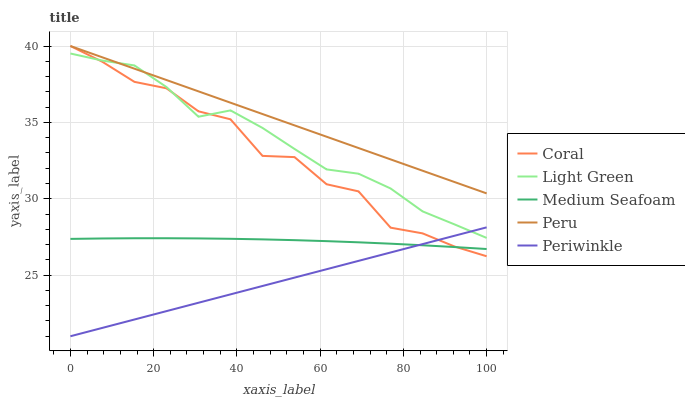Does Periwinkle have the minimum area under the curve?
Answer yes or no. Yes. Does Peru have the maximum area under the curve?
Answer yes or no. Yes. Does Coral have the minimum area under the curve?
Answer yes or no. No. Does Coral have the maximum area under the curve?
Answer yes or no. No. Is Periwinkle the smoothest?
Answer yes or no. Yes. Is Coral the roughest?
Answer yes or no. Yes. Is Coral the smoothest?
Answer yes or no. No. Is Periwinkle the roughest?
Answer yes or no. No. Does Periwinkle have the lowest value?
Answer yes or no. Yes. Does Coral have the lowest value?
Answer yes or no. No. Does Coral have the highest value?
Answer yes or no. Yes. Does Periwinkle have the highest value?
Answer yes or no. No. Is Periwinkle less than Peru?
Answer yes or no. Yes. Is Light Green greater than Medium Seafoam?
Answer yes or no. Yes. Does Light Green intersect Peru?
Answer yes or no. Yes. Is Light Green less than Peru?
Answer yes or no. No. Is Light Green greater than Peru?
Answer yes or no. No. Does Periwinkle intersect Peru?
Answer yes or no. No. 